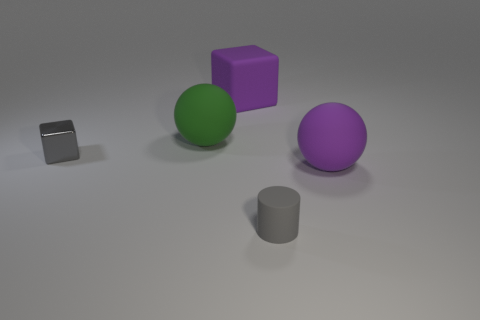Does the purple thing left of the gray cylinder have the same shape as the tiny gray metallic thing?
Make the answer very short. Yes. The big block that is the same material as the small gray cylinder is what color?
Give a very brief answer. Purple. There is a purple thing behind the tiny gray metallic block; what material is it?
Provide a succinct answer. Rubber. Does the tiny gray shiny thing have the same shape as the big rubber thing that is in front of the green matte object?
Your answer should be very brief. No. There is a thing that is both behind the purple sphere and in front of the green thing; what material is it?
Offer a terse response. Metal. There is another rubber ball that is the same size as the purple rubber sphere; what is its color?
Provide a succinct answer. Green. Do the big purple block and the tiny gray thing that is behind the big purple ball have the same material?
Give a very brief answer. No. How many other things are the same size as the purple rubber ball?
Your answer should be very brief. 2. Are there any small gray metallic cubes in front of the small gray thing to the right of the big rubber sphere that is left of the purple rubber block?
Make the answer very short. No. The gray cube has what size?
Your response must be concise. Small. 